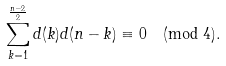Convert formula to latex. <formula><loc_0><loc_0><loc_500><loc_500>\sum _ { k = 1 } ^ { \frac { n - 2 } { 2 } } d ( k ) d ( n - k ) \equiv 0 \pmod { 4 } .</formula> 